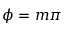<formula> <loc_0><loc_0><loc_500><loc_500>\phi = m \pi</formula> 